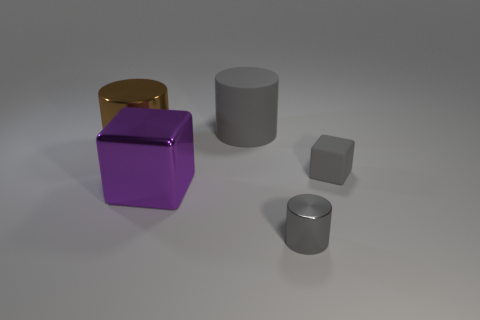What is the material of the tiny cylinder?
Keep it short and to the point. Metal. Are there any rubber cylinders of the same size as the brown metal cylinder?
Provide a succinct answer. Yes. What is the material of the cube that is the same size as the gray metallic thing?
Provide a short and direct response. Rubber. How many purple cubes are there?
Give a very brief answer. 1. There is a cube that is to the left of the rubber cube; how big is it?
Your response must be concise. Large. Are there the same number of large gray objects behind the tiny cylinder and large purple blocks?
Your answer should be very brief. Yes. Is there a gray thing that has the same shape as the purple object?
Your answer should be very brief. Yes. There is a large object that is to the left of the matte cylinder and behind the large purple block; what shape is it?
Your response must be concise. Cylinder. Do the purple object and the block behind the large purple object have the same material?
Offer a terse response. No. Are there any small metallic objects on the left side of the big gray rubber object?
Give a very brief answer. No. 